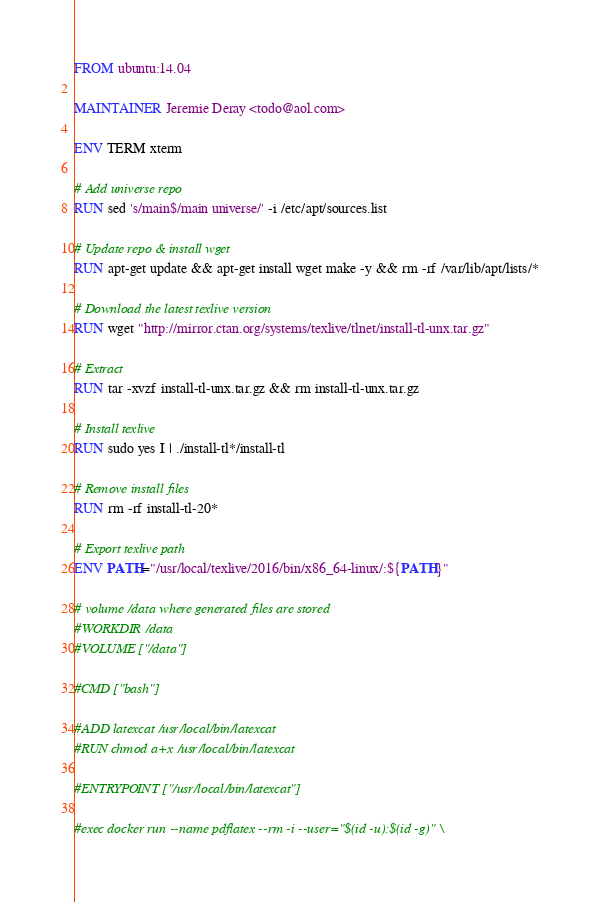<code> <loc_0><loc_0><loc_500><loc_500><_Dockerfile_>FROM ubuntu:14.04

MAINTAINER Jeremie Deray <todo@aol.com>

ENV TERM xterm

# Add universe repo
RUN sed 's/main$/main universe/' -i /etc/apt/sources.list

# Update repo & install wget
RUN apt-get update && apt-get install wget make -y && rm -rf /var/lib/apt/lists/*

# Download the latest texlive version
RUN wget "http://mirror.ctan.org/systems/texlive/tlnet/install-tl-unx.tar.gz"

# Extract
RUN tar -xvzf install-tl-unx.tar.gz && rm install-tl-unx.tar.gz

# Install texlive
RUN sudo yes I | ./install-tl*/install-tl

# Remove install files
RUN rm -rf install-tl-20*

# Export texlive path
ENV PATH="/usr/local/texlive/2016/bin/x86_64-linux/:${PATH}"

# volume /data where generated files are stored
#WORKDIR /data
#VOLUME ["/data"]

#CMD ["bash"]

#ADD latexcat /usr/local/bin/latexcat
#RUN chmod a+x /usr/local/bin/latexcat

#ENTRYPOINT ["/usr/local/bin/latexcat"]

#exec docker run --name pdflatex --rm -i --user="$(id -u):$(id -g)" \</code> 